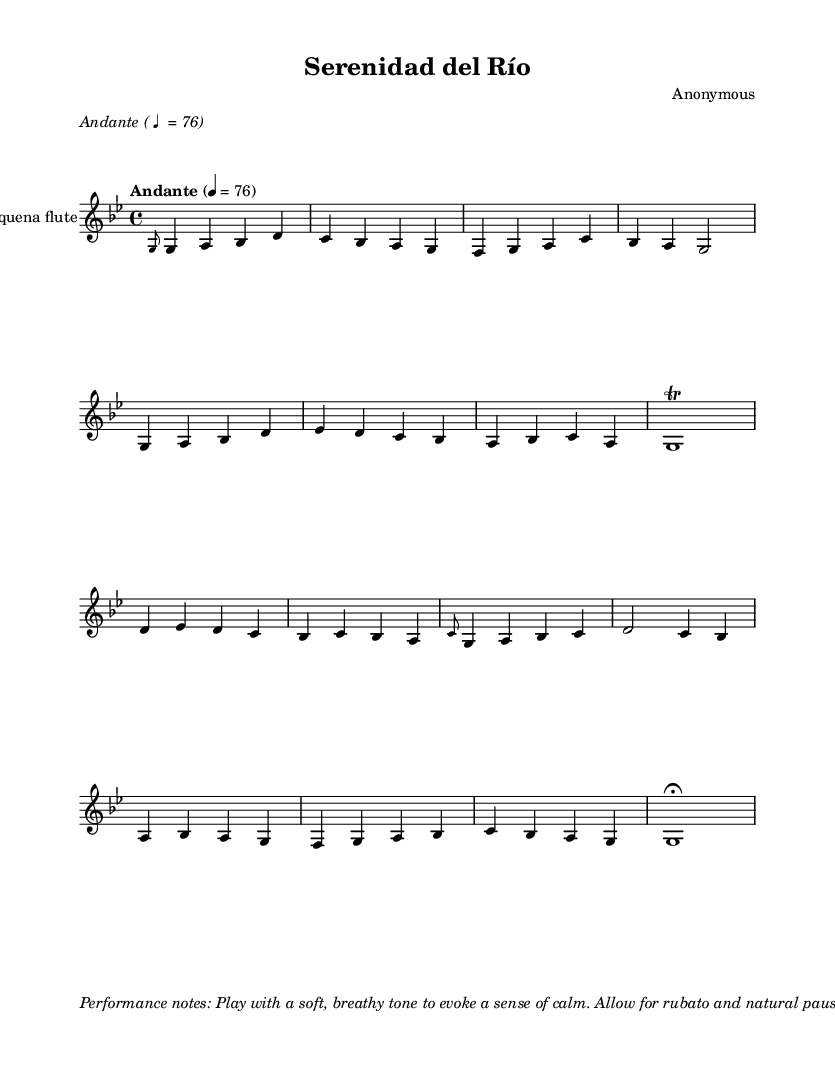What is the key signature of this music? The key signature is G minor, indicated by the presence of two flats (B♭ and E♭) at the beginning of the staff.
Answer: G minor What is the time signature of this piece? The time signature shown at the beginning of the score is 4/4, indicating there are four beats in each measure.
Answer: 4/4 What is the tempo marking for this music? The tempo marking states "Andante," which suggests a moderate walking pace, typically around 76 beats per minute.
Answer: Andante How many measures are in the music score? By counting the measures between the double bar lines in the staff, there are a total of eight measures present.
Answer: Eight What is the performance style suggested in the notes? The performance notes indicate to play with a soft, breathy tone and to allow rubato and natural pauses, which enhances the calm atmosphere of the piece.
Answer: Soft, breathy tone What instrument is specified for this piece? The score explicitly names the "Andean quena flute" as the instrument to be used for this music, highlighting its cultural significance.
Answer: Andean quena flute What is the highest note in the melody? Looking at the melody on the staff, the highest note played is D', located on the second line of the staff with a notehead placed above the first line.
Answer: D' 